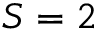Convert formula to latex. <formula><loc_0><loc_0><loc_500><loc_500>S = 2</formula> 